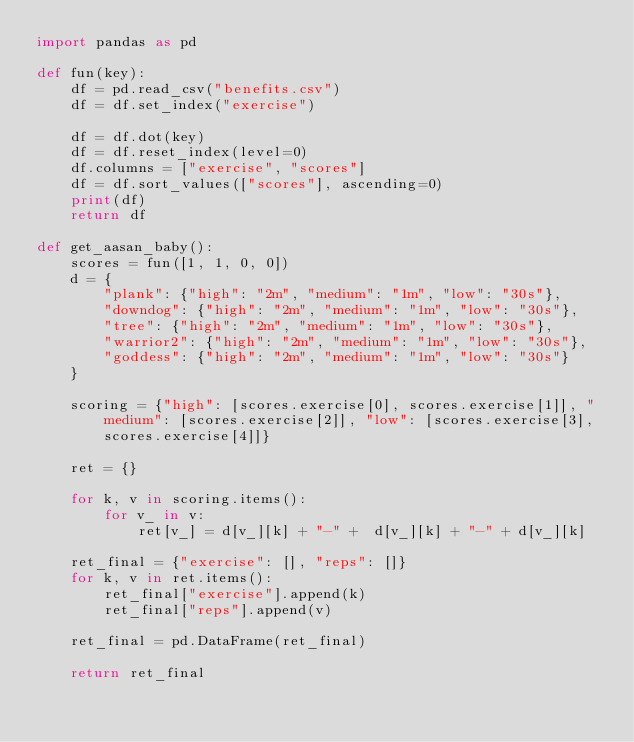Convert code to text. <code><loc_0><loc_0><loc_500><loc_500><_Python_>import pandas as pd 

def fun(key):
    df = pd.read_csv("benefits.csv")
    df = df.set_index("exercise")
    
    df = df.dot(key)
    df = df.reset_index(level=0)
    df.columns = ["exercise", "scores"]
    df = df.sort_values(["scores"], ascending=0)
    print(df)
    return df

def get_aasan_baby():
    scores = fun([1, 1, 0, 0])
    d = {
        "plank": {"high": "2m", "medium": "1m", "low": "30s"},
        "downdog": {"high": "2m", "medium": "1m", "low": "30s"},
        "tree": {"high": "2m", "medium": "1m", "low": "30s"},
        "warrior2": {"high": "2m", "medium": "1m", "low": "30s"},
        "goddess": {"high": "2m", "medium": "1m", "low": "30s"}
    }

    scoring = {"high": [scores.exercise[0], scores.exercise[1]], "medium": [scores.exercise[2]], "low": [scores.exercise[3], scores.exercise[4]]}

    ret = {}

    for k, v in scoring.items():
        for v_ in v:
            ret[v_] = d[v_][k] + "-" +  d[v_][k] + "-" + d[v_][k]
    
    ret_final = {"exercise": [], "reps": []}
    for k, v in ret.items():
        ret_final["exercise"].append(k)
        ret_final["reps"].append(v)
    
    ret_final = pd.DataFrame(ret_final)
    
    return ret_final



</code> 